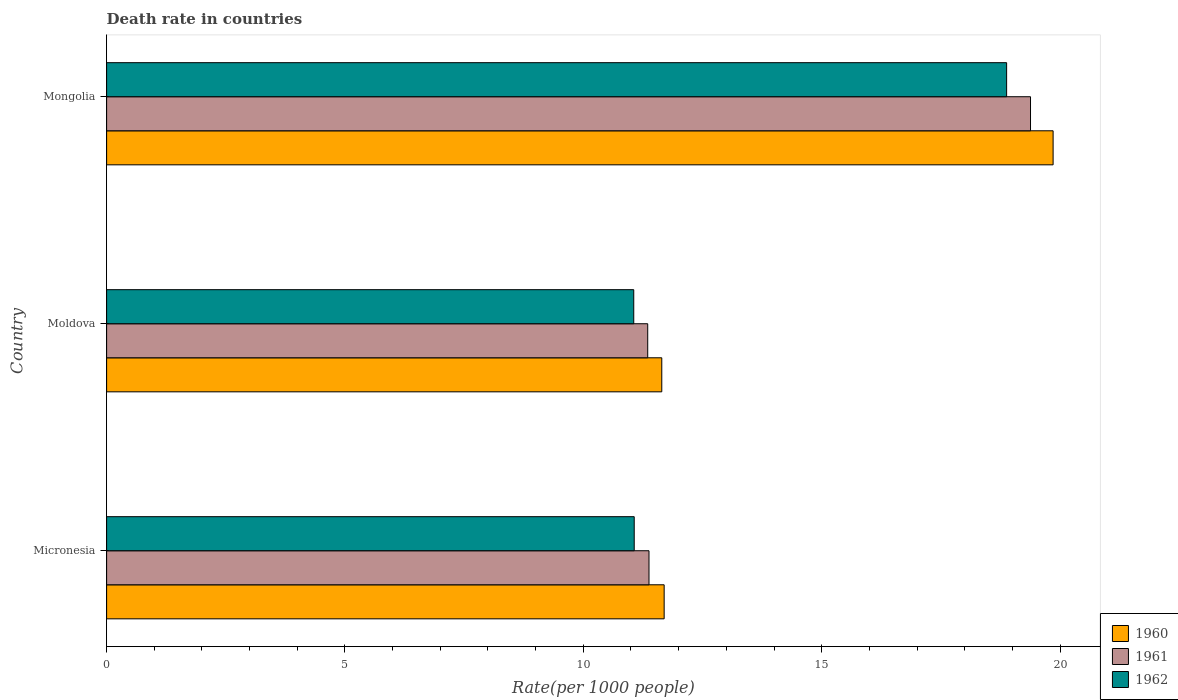How many different coloured bars are there?
Your answer should be very brief. 3. Are the number of bars on each tick of the Y-axis equal?
Your answer should be compact. Yes. How many bars are there on the 2nd tick from the bottom?
Your response must be concise. 3. What is the label of the 2nd group of bars from the top?
Give a very brief answer. Moldova. What is the death rate in 1962 in Micronesia?
Offer a very short reply. 11.07. Across all countries, what is the maximum death rate in 1961?
Make the answer very short. 19.38. Across all countries, what is the minimum death rate in 1960?
Your response must be concise. 11.65. In which country was the death rate in 1961 maximum?
Give a very brief answer. Mongolia. In which country was the death rate in 1962 minimum?
Offer a very short reply. Moldova. What is the total death rate in 1961 in the graph?
Make the answer very short. 42.11. What is the difference between the death rate in 1960 in Micronesia and that in Mongolia?
Give a very brief answer. -8.16. What is the difference between the death rate in 1960 in Moldova and the death rate in 1962 in Micronesia?
Offer a very short reply. 0.58. What is the average death rate in 1960 per country?
Your answer should be compact. 14.4. What is the difference between the death rate in 1961 and death rate in 1962 in Mongolia?
Your answer should be compact. 0.5. What is the ratio of the death rate in 1961 in Micronesia to that in Mongolia?
Keep it short and to the point. 0.59. Is the death rate in 1960 in Moldova less than that in Mongolia?
Your response must be concise. Yes. Is the difference between the death rate in 1961 in Micronesia and Mongolia greater than the difference between the death rate in 1962 in Micronesia and Mongolia?
Make the answer very short. No. What is the difference between the highest and the second highest death rate in 1960?
Give a very brief answer. 8.16. What is the difference between the highest and the lowest death rate in 1960?
Your answer should be very brief. 8.21. Is the sum of the death rate in 1960 in Micronesia and Mongolia greater than the maximum death rate in 1962 across all countries?
Keep it short and to the point. Yes. What does the 2nd bar from the bottom in Micronesia represents?
Provide a succinct answer. 1961. Is it the case that in every country, the sum of the death rate in 1962 and death rate in 1961 is greater than the death rate in 1960?
Your answer should be very brief. Yes. How many countries are there in the graph?
Offer a terse response. 3. What is the difference between two consecutive major ticks on the X-axis?
Provide a succinct answer. 5. Are the values on the major ticks of X-axis written in scientific E-notation?
Make the answer very short. No. Where does the legend appear in the graph?
Make the answer very short. Bottom right. What is the title of the graph?
Provide a short and direct response. Death rate in countries. What is the label or title of the X-axis?
Give a very brief answer. Rate(per 1000 people). What is the Rate(per 1000 people) of 1960 in Micronesia?
Provide a short and direct response. 11.7. What is the Rate(per 1000 people) of 1961 in Micronesia?
Your answer should be very brief. 11.38. What is the Rate(per 1000 people) of 1962 in Micronesia?
Provide a succinct answer. 11.07. What is the Rate(per 1000 people) of 1960 in Moldova?
Provide a succinct answer. 11.65. What is the Rate(per 1000 people) in 1961 in Moldova?
Provide a succinct answer. 11.35. What is the Rate(per 1000 people) of 1962 in Moldova?
Offer a very short reply. 11.06. What is the Rate(per 1000 people) in 1960 in Mongolia?
Your answer should be very brief. 19.86. What is the Rate(per 1000 people) in 1961 in Mongolia?
Give a very brief answer. 19.38. What is the Rate(per 1000 people) of 1962 in Mongolia?
Offer a very short reply. 18.88. Across all countries, what is the maximum Rate(per 1000 people) of 1960?
Offer a very short reply. 19.86. Across all countries, what is the maximum Rate(per 1000 people) of 1961?
Keep it short and to the point. 19.38. Across all countries, what is the maximum Rate(per 1000 people) of 1962?
Provide a succinct answer. 18.88. Across all countries, what is the minimum Rate(per 1000 people) in 1960?
Give a very brief answer. 11.65. Across all countries, what is the minimum Rate(per 1000 people) in 1961?
Give a very brief answer. 11.35. Across all countries, what is the minimum Rate(per 1000 people) of 1962?
Offer a terse response. 11.06. What is the total Rate(per 1000 people) in 1960 in the graph?
Make the answer very short. 43.2. What is the total Rate(per 1000 people) of 1961 in the graph?
Your answer should be very brief. 42.11. What is the total Rate(per 1000 people) of 1962 in the graph?
Your response must be concise. 41.01. What is the difference between the Rate(per 1000 people) in 1961 in Micronesia and that in Moldova?
Provide a succinct answer. 0.03. What is the difference between the Rate(per 1000 people) of 1960 in Micronesia and that in Mongolia?
Your answer should be compact. -8.16. What is the difference between the Rate(per 1000 people) of 1961 in Micronesia and that in Mongolia?
Your answer should be very brief. -8. What is the difference between the Rate(per 1000 people) of 1962 in Micronesia and that in Mongolia?
Your answer should be compact. -7.81. What is the difference between the Rate(per 1000 people) in 1960 in Moldova and that in Mongolia?
Offer a terse response. -8.21. What is the difference between the Rate(per 1000 people) in 1961 in Moldova and that in Mongolia?
Offer a terse response. -8.03. What is the difference between the Rate(per 1000 people) of 1962 in Moldova and that in Mongolia?
Provide a short and direct response. -7.82. What is the difference between the Rate(per 1000 people) of 1960 in Micronesia and the Rate(per 1000 people) of 1961 in Moldova?
Your response must be concise. 0.34. What is the difference between the Rate(per 1000 people) in 1960 in Micronesia and the Rate(per 1000 people) in 1962 in Moldova?
Offer a terse response. 0.64. What is the difference between the Rate(per 1000 people) of 1961 in Micronesia and the Rate(per 1000 people) of 1962 in Moldova?
Give a very brief answer. 0.32. What is the difference between the Rate(per 1000 people) in 1960 in Micronesia and the Rate(per 1000 people) in 1961 in Mongolia?
Keep it short and to the point. -7.68. What is the difference between the Rate(per 1000 people) of 1960 in Micronesia and the Rate(per 1000 people) of 1962 in Mongolia?
Your answer should be very brief. -7.18. What is the difference between the Rate(per 1000 people) of 1961 in Micronesia and the Rate(per 1000 people) of 1962 in Mongolia?
Ensure brevity in your answer.  -7.5. What is the difference between the Rate(per 1000 people) in 1960 in Moldova and the Rate(per 1000 people) in 1961 in Mongolia?
Make the answer very short. -7.74. What is the difference between the Rate(per 1000 people) in 1960 in Moldova and the Rate(per 1000 people) in 1962 in Mongolia?
Provide a succinct answer. -7.23. What is the difference between the Rate(per 1000 people) of 1961 in Moldova and the Rate(per 1000 people) of 1962 in Mongolia?
Offer a very short reply. -7.53. What is the average Rate(per 1000 people) in 1960 per country?
Keep it short and to the point. 14.4. What is the average Rate(per 1000 people) of 1961 per country?
Provide a succinct answer. 14.04. What is the average Rate(per 1000 people) in 1962 per country?
Your answer should be compact. 13.67. What is the difference between the Rate(per 1000 people) of 1960 and Rate(per 1000 people) of 1961 in Micronesia?
Offer a terse response. 0.32. What is the difference between the Rate(per 1000 people) in 1960 and Rate(per 1000 people) in 1962 in Micronesia?
Your response must be concise. 0.63. What is the difference between the Rate(per 1000 people) of 1961 and Rate(per 1000 people) of 1962 in Micronesia?
Provide a succinct answer. 0.31. What is the difference between the Rate(per 1000 people) of 1960 and Rate(per 1000 people) of 1961 in Moldova?
Give a very brief answer. 0.29. What is the difference between the Rate(per 1000 people) in 1960 and Rate(per 1000 people) in 1962 in Moldova?
Your answer should be compact. 0.59. What is the difference between the Rate(per 1000 people) in 1961 and Rate(per 1000 people) in 1962 in Moldova?
Make the answer very short. 0.29. What is the difference between the Rate(per 1000 people) in 1960 and Rate(per 1000 people) in 1961 in Mongolia?
Offer a terse response. 0.47. What is the difference between the Rate(per 1000 people) in 1961 and Rate(per 1000 people) in 1962 in Mongolia?
Keep it short and to the point. 0.5. What is the ratio of the Rate(per 1000 people) of 1960 in Micronesia to that in Moldova?
Keep it short and to the point. 1. What is the ratio of the Rate(per 1000 people) of 1961 in Micronesia to that in Moldova?
Give a very brief answer. 1. What is the ratio of the Rate(per 1000 people) in 1962 in Micronesia to that in Moldova?
Offer a very short reply. 1. What is the ratio of the Rate(per 1000 people) in 1960 in Micronesia to that in Mongolia?
Provide a succinct answer. 0.59. What is the ratio of the Rate(per 1000 people) in 1961 in Micronesia to that in Mongolia?
Ensure brevity in your answer.  0.59. What is the ratio of the Rate(per 1000 people) in 1962 in Micronesia to that in Mongolia?
Give a very brief answer. 0.59. What is the ratio of the Rate(per 1000 people) of 1960 in Moldova to that in Mongolia?
Offer a very short reply. 0.59. What is the ratio of the Rate(per 1000 people) of 1961 in Moldova to that in Mongolia?
Keep it short and to the point. 0.59. What is the ratio of the Rate(per 1000 people) of 1962 in Moldova to that in Mongolia?
Offer a terse response. 0.59. What is the difference between the highest and the second highest Rate(per 1000 people) of 1960?
Your answer should be very brief. 8.16. What is the difference between the highest and the second highest Rate(per 1000 people) in 1961?
Provide a short and direct response. 8. What is the difference between the highest and the second highest Rate(per 1000 people) of 1962?
Offer a terse response. 7.81. What is the difference between the highest and the lowest Rate(per 1000 people) in 1960?
Ensure brevity in your answer.  8.21. What is the difference between the highest and the lowest Rate(per 1000 people) in 1961?
Give a very brief answer. 8.03. What is the difference between the highest and the lowest Rate(per 1000 people) in 1962?
Give a very brief answer. 7.82. 